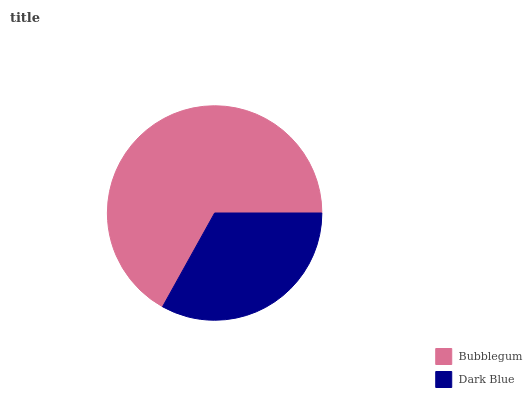Is Dark Blue the minimum?
Answer yes or no. Yes. Is Bubblegum the maximum?
Answer yes or no. Yes. Is Dark Blue the maximum?
Answer yes or no. No. Is Bubblegum greater than Dark Blue?
Answer yes or no. Yes. Is Dark Blue less than Bubblegum?
Answer yes or no. Yes. Is Dark Blue greater than Bubblegum?
Answer yes or no. No. Is Bubblegum less than Dark Blue?
Answer yes or no. No. Is Bubblegum the high median?
Answer yes or no. Yes. Is Dark Blue the low median?
Answer yes or no. Yes. Is Dark Blue the high median?
Answer yes or no. No. Is Bubblegum the low median?
Answer yes or no. No. 